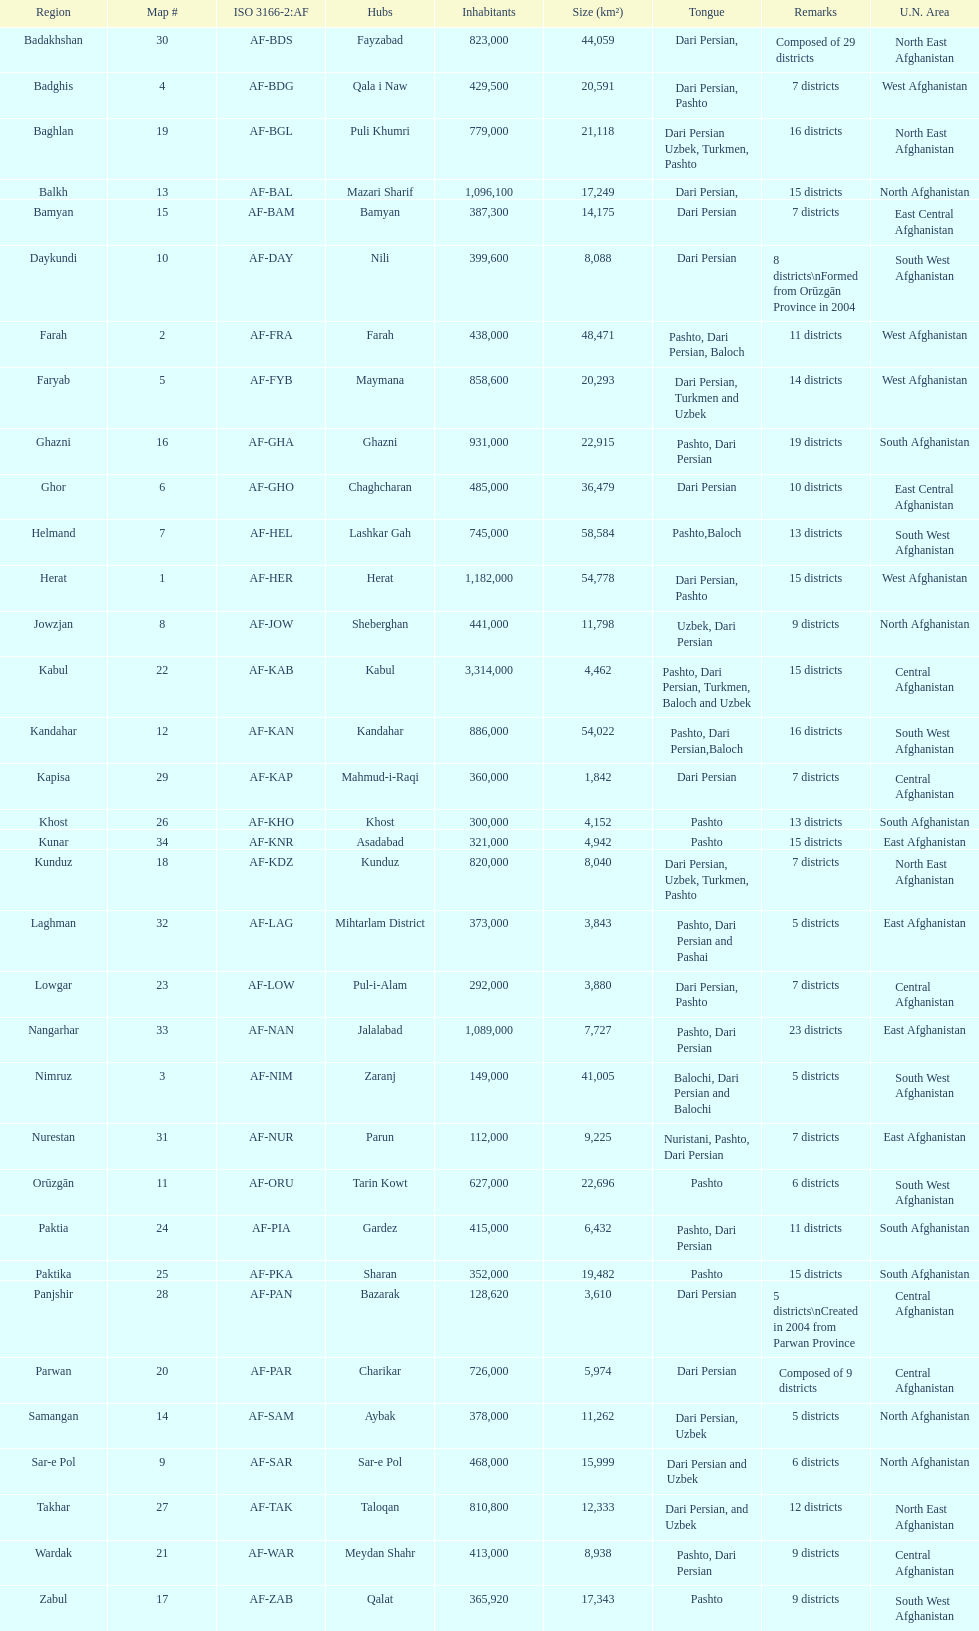How many provinces in afghanistan speak dari persian? 28. 